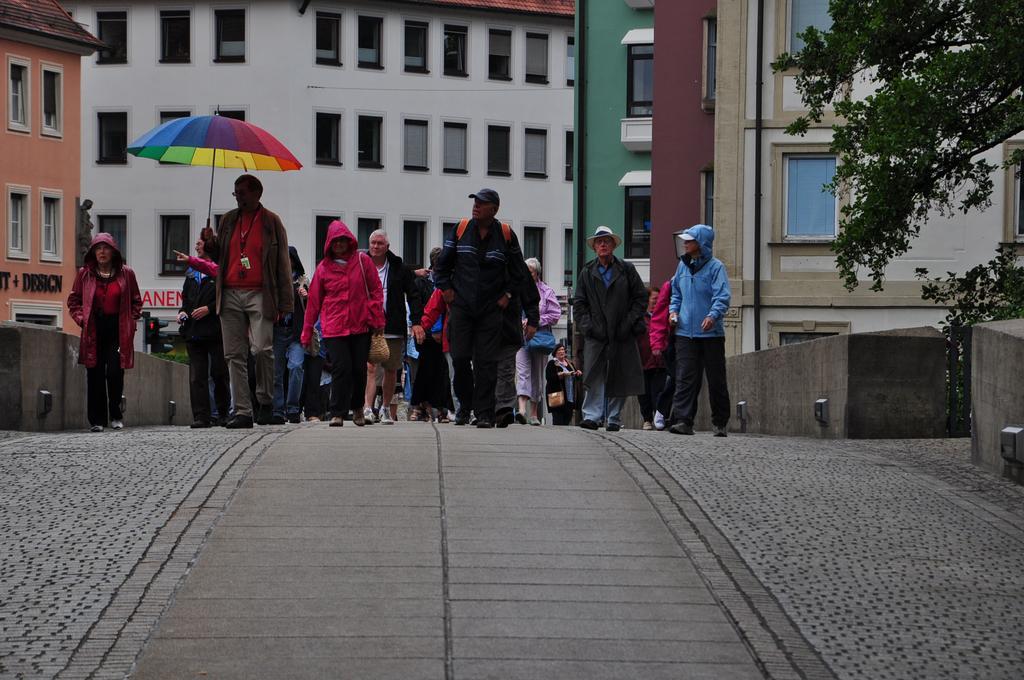Can you describe this image briefly? In this image I can see group of people walking on the road. In front the person is holding an umbrella and the umbrella is in multi color. Background I can see few buildings in white, brown and cream color and I can see few trees in green color. 